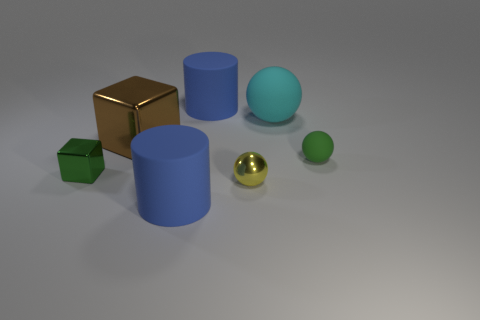What number of small blocks have the same color as the tiny rubber ball?
Ensure brevity in your answer.  1. The tiny green object right of the small shiny thing that is behind the yellow metallic ball is what shape?
Ensure brevity in your answer.  Sphere. What number of big things have the same material as the small yellow ball?
Offer a very short reply. 1. What is the tiny green thing that is to the left of the small green ball made of?
Give a very brief answer. Metal. There is a rubber object that is in front of the tiny shiny object that is on the right side of the thing that is to the left of the large brown shiny cube; what is its shape?
Your answer should be very brief. Cylinder. Do the cylinder behind the large metallic object and the thing in front of the tiny yellow object have the same color?
Offer a terse response. Yes. Are there fewer brown objects that are in front of the large sphere than large things behind the yellow shiny ball?
Keep it short and to the point. Yes. What color is the tiny metallic object that is the same shape as the large cyan rubber thing?
Keep it short and to the point. Yellow. There is a small green metallic thing; is it the same shape as the blue matte object in front of the small green block?
Offer a terse response. No. How many objects are either matte things behind the cyan matte ball or matte things behind the tiny green shiny cube?
Provide a short and direct response. 3. 